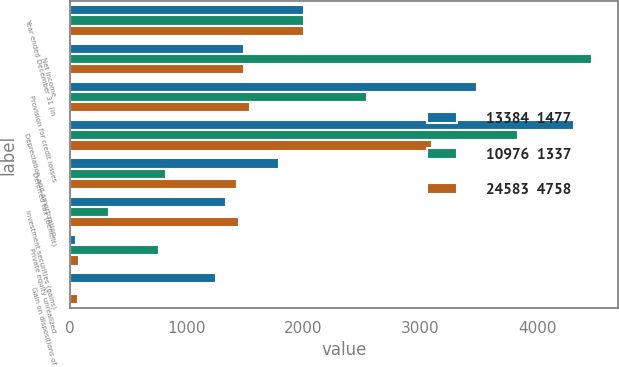<chart> <loc_0><loc_0><loc_500><loc_500><stacked_bar_chart><ecel><fcel>Year ended December 31 (in<fcel>Net income<fcel>Provision for credit losses<fcel>Depreciation and amortization<fcel>Deferred tax (benefit)<fcel>Investment securities (gains)<fcel>Private equity unrealized<fcel>Gain on dispositions of<nl><fcel>13384  1477<fcel>2005<fcel>1493<fcel>3483<fcel>4318<fcel>1791<fcel>1336<fcel>55<fcel>1254<nl><fcel>10976  1337<fcel>2004<fcel>4466<fcel>2544<fcel>3835<fcel>827<fcel>338<fcel>766<fcel>17<nl><fcel>24583  4758<fcel>2003<fcel>1493<fcel>1540<fcel>3101<fcel>1428<fcel>1446<fcel>77<fcel>68<nl></chart> 